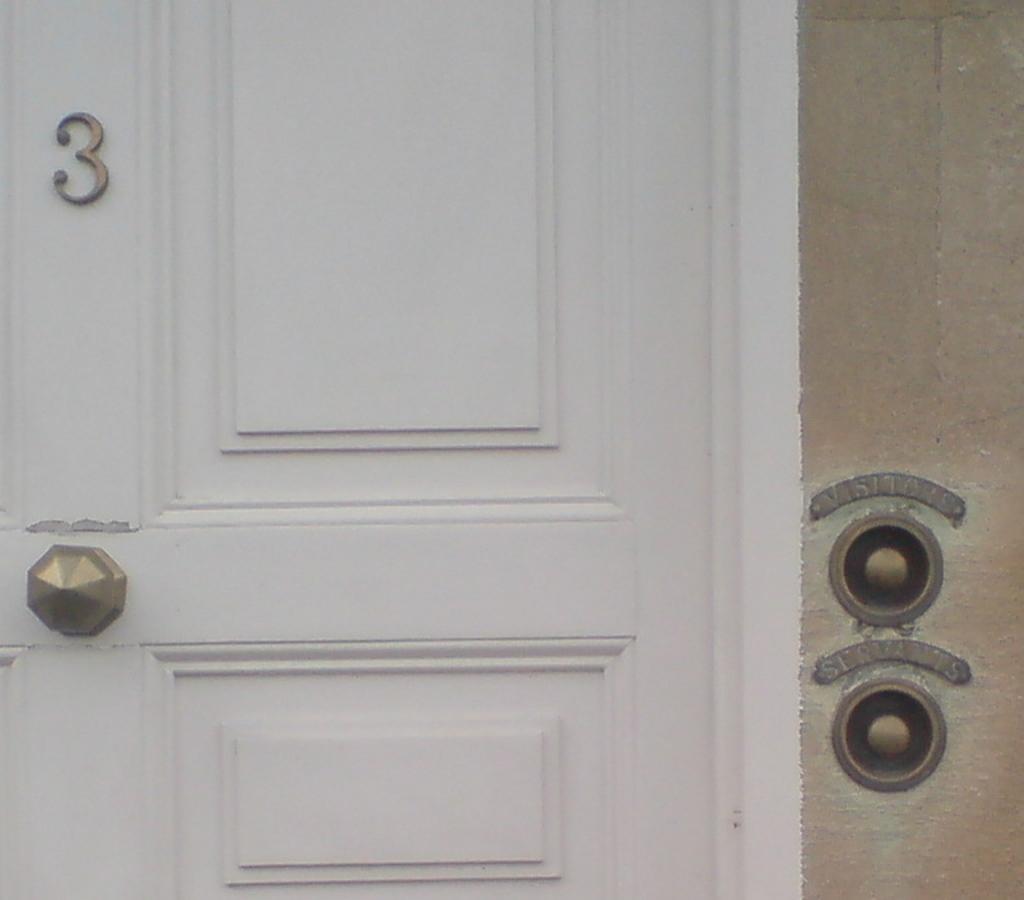How would you summarize this image in a sentence or two? In this image there is a door to the wall. To the left there is a knob to the door. Above to it there is a number 3 on the door. 